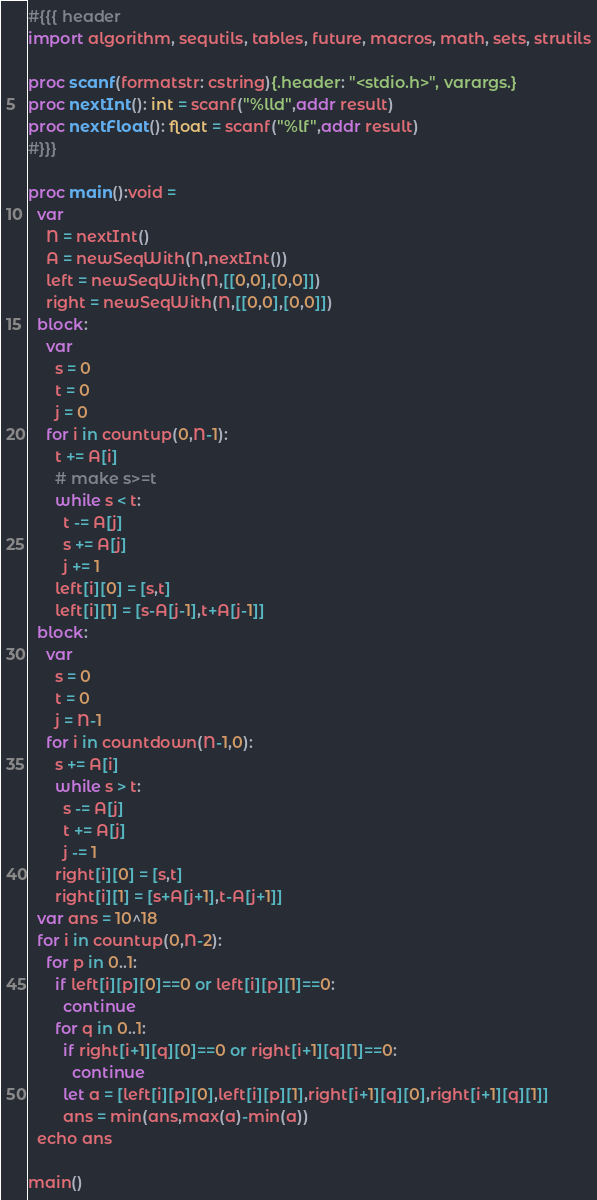<code> <loc_0><loc_0><loc_500><loc_500><_Nim_>#{{{ header
import algorithm, sequtils, tables, future, macros, math, sets, strutils
 
proc scanf(formatstr: cstring){.header: "<stdio.h>", varargs.}
proc nextInt(): int = scanf("%lld",addr result)
proc nextFloat(): float = scanf("%lf",addr result)
#}}}

proc main():void =
  var
    N = nextInt()
    A = newSeqWith(N,nextInt())
    left = newSeqWith(N,[[0,0],[0,0]])
    right = newSeqWith(N,[[0,0],[0,0]])
  block:
    var
      s = 0
      t = 0
      j = 0
    for i in countup(0,N-1):
      t += A[i]
      # make s>=t
      while s < t:
        t -= A[j]
        s += A[j]
        j += 1
      left[i][0] = [s,t]
      left[i][1] = [s-A[j-1],t+A[j-1]]
  block:
    var
      s = 0
      t = 0
      j = N-1
    for i in countdown(N-1,0):
      s += A[i]
      while s > t:
        s -= A[j]
        t += A[j]
        j -= 1
      right[i][0] = [s,t]
      right[i][1] = [s+A[j+1],t-A[j+1]]
  var ans = 10^18
  for i in countup(0,N-2):
    for p in 0..1:
      if left[i][p][0]==0 or left[i][p][1]==0:
        continue
      for q in 0..1:
        if right[i+1][q][0]==0 or right[i+1][q][1]==0:
          continue
        let a = [left[i][p][0],left[i][p][1],right[i+1][q][0],right[i+1][q][1]]
        ans = min(ans,max(a)-min(a))
  echo ans

main()
</code> 